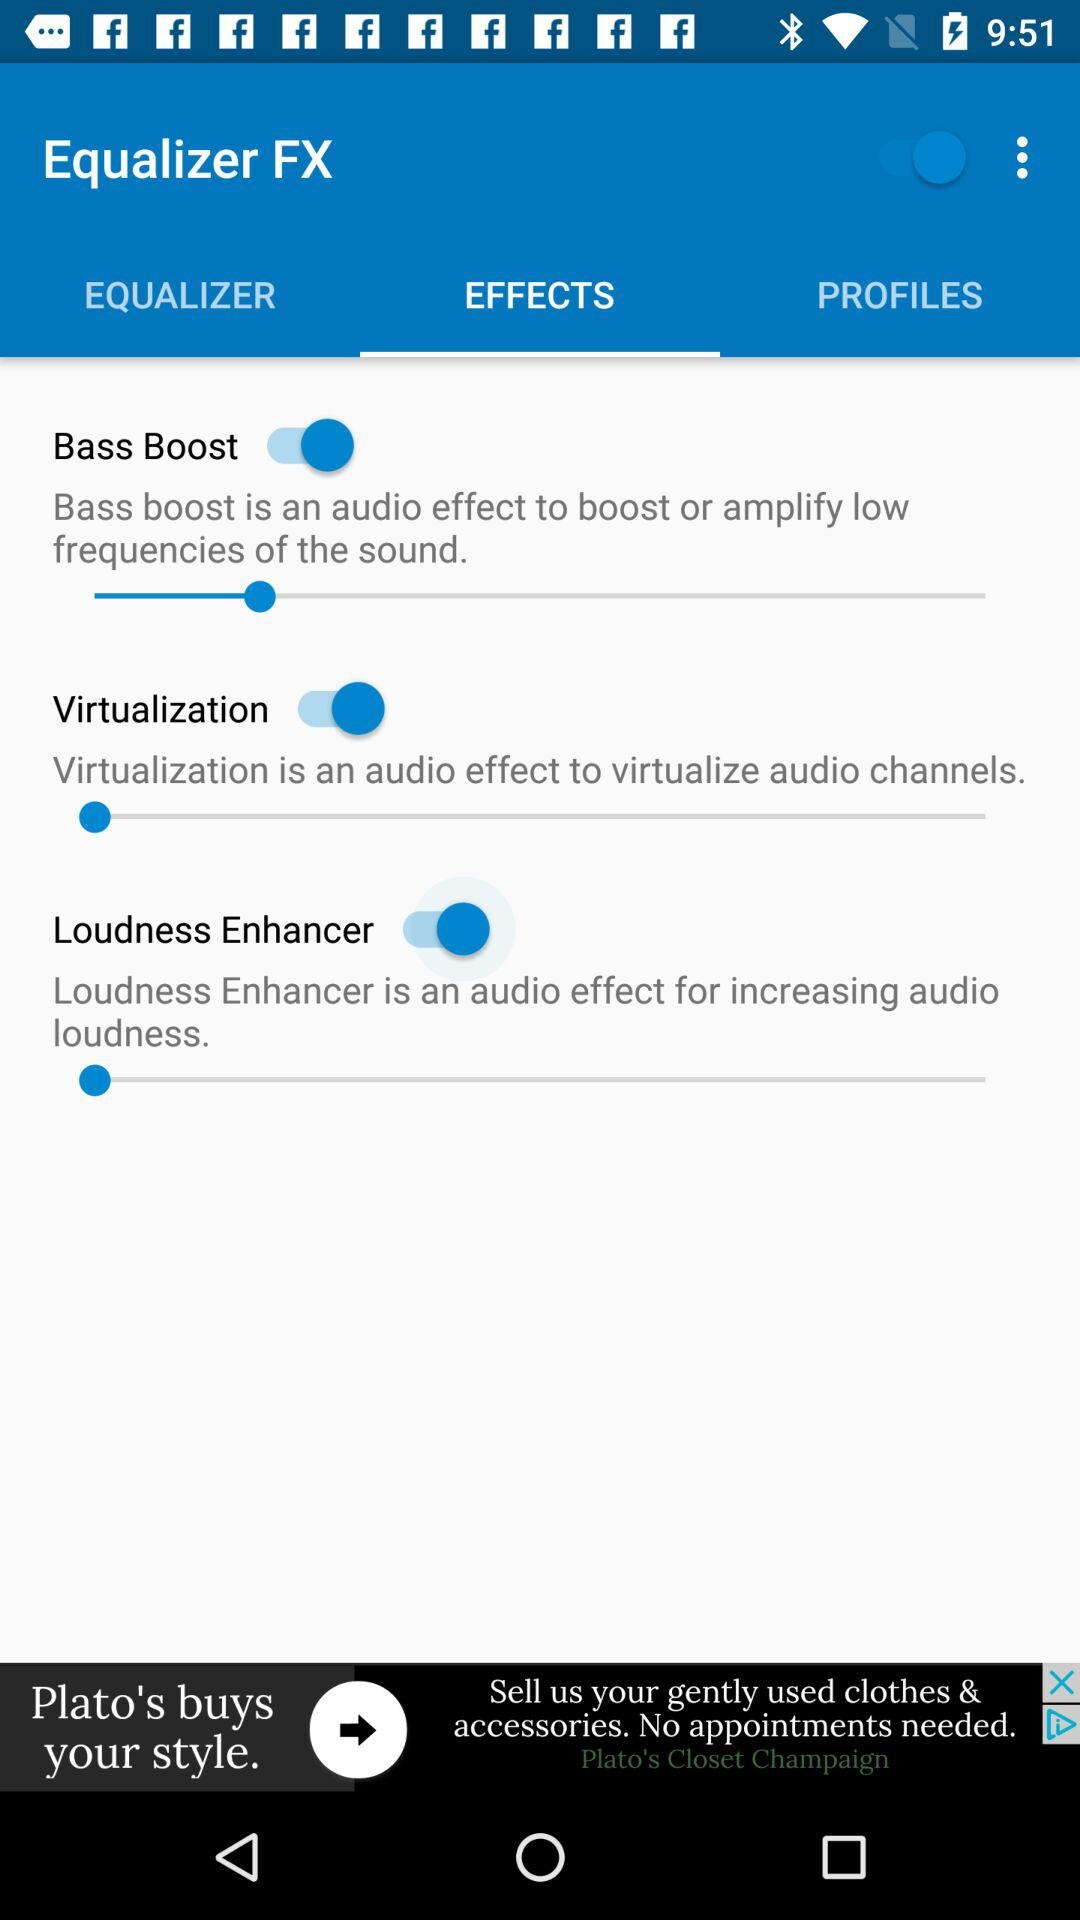What is the status of "Bass Boost"? The status of "Bass Boost" is "on". 